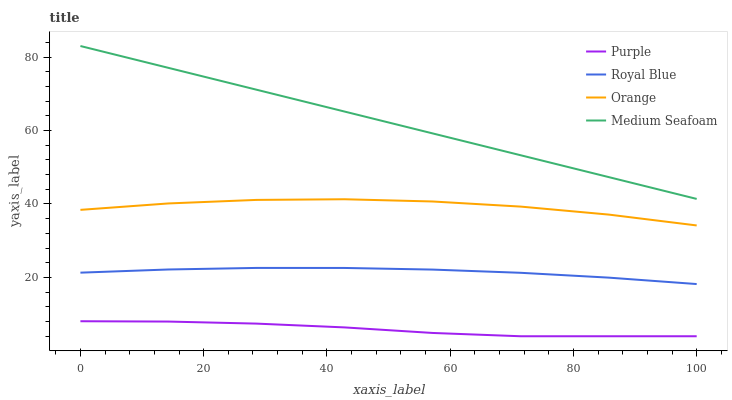Does Purple have the minimum area under the curve?
Answer yes or no. Yes. Does Medium Seafoam have the maximum area under the curve?
Answer yes or no. Yes. Does Royal Blue have the minimum area under the curve?
Answer yes or no. No. Does Royal Blue have the maximum area under the curve?
Answer yes or no. No. Is Medium Seafoam the smoothest?
Answer yes or no. Yes. Is Orange the roughest?
Answer yes or no. Yes. Is Royal Blue the smoothest?
Answer yes or no. No. Is Royal Blue the roughest?
Answer yes or no. No. Does Royal Blue have the lowest value?
Answer yes or no. No. Does Medium Seafoam have the highest value?
Answer yes or no. Yes. Does Royal Blue have the highest value?
Answer yes or no. No. Is Orange less than Medium Seafoam?
Answer yes or no. Yes. Is Medium Seafoam greater than Orange?
Answer yes or no. Yes. Does Orange intersect Medium Seafoam?
Answer yes or no. No. 